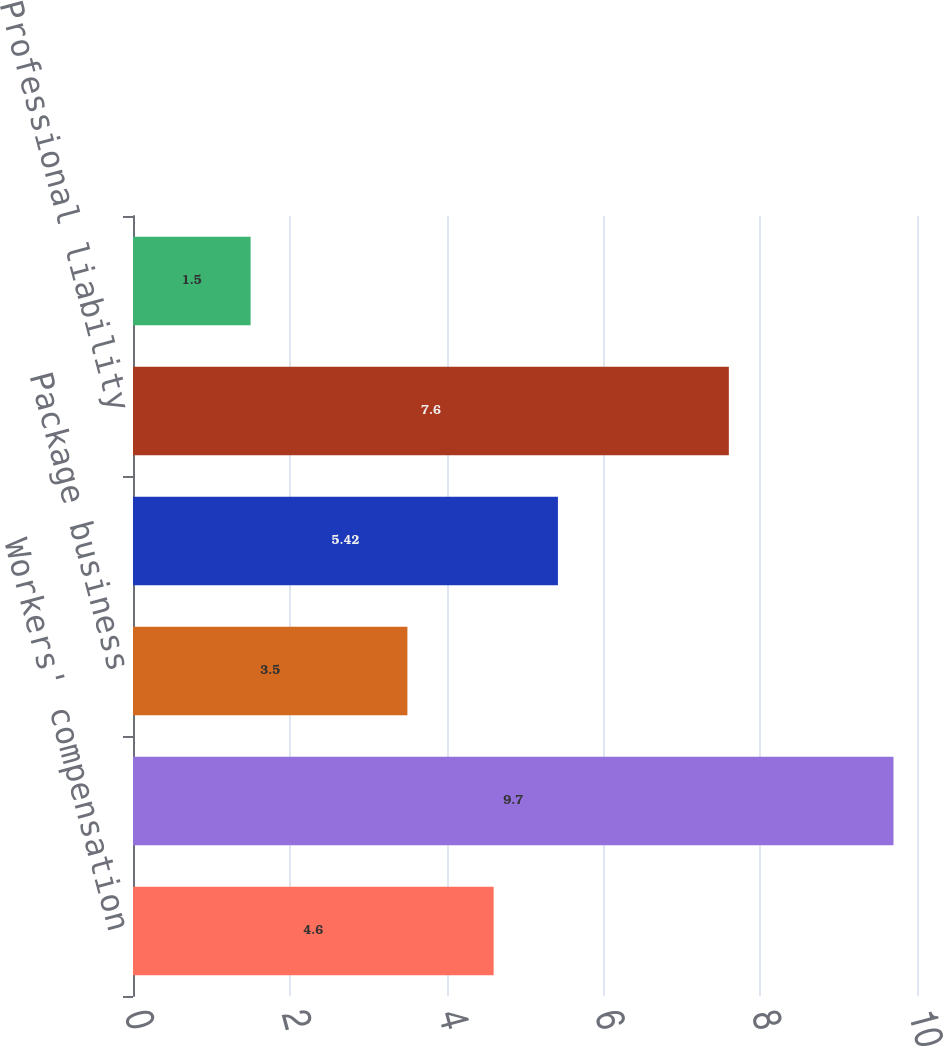Convert chart to OTSL. <chart><loc_0><loc_0><loc_500><loc_500><bar_chart><fcel>Workers' compensation<fcel>General liability<fcel>Package business<fcel>Commercial automobile<fcel>Professional liability<fcel>Bond<nl><fcel>4.6<fcel>9.7<fcel>3.5<fcel>5.42<fcel>7.6<fcel>1.5<nl></chart> 